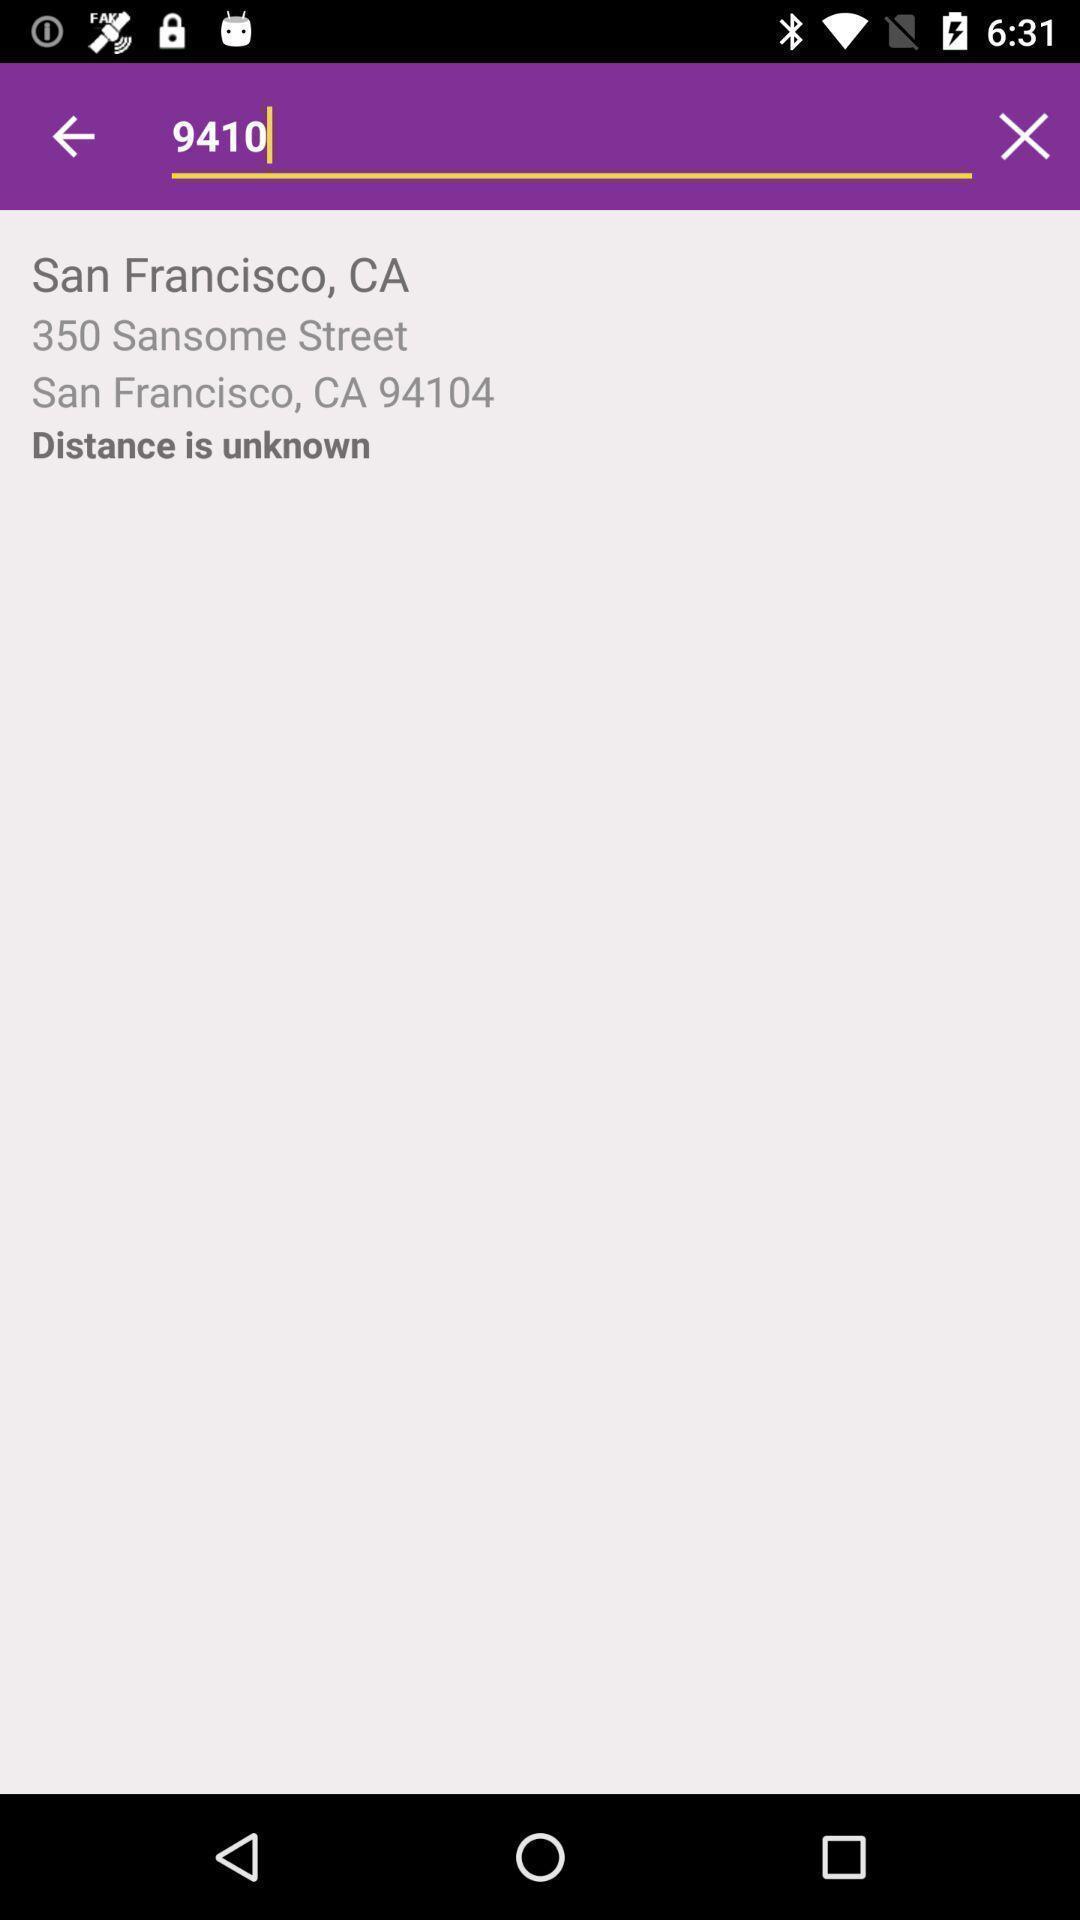Provide a detailed account of this screenshot. Search bar for locating the gym on fitness app. 